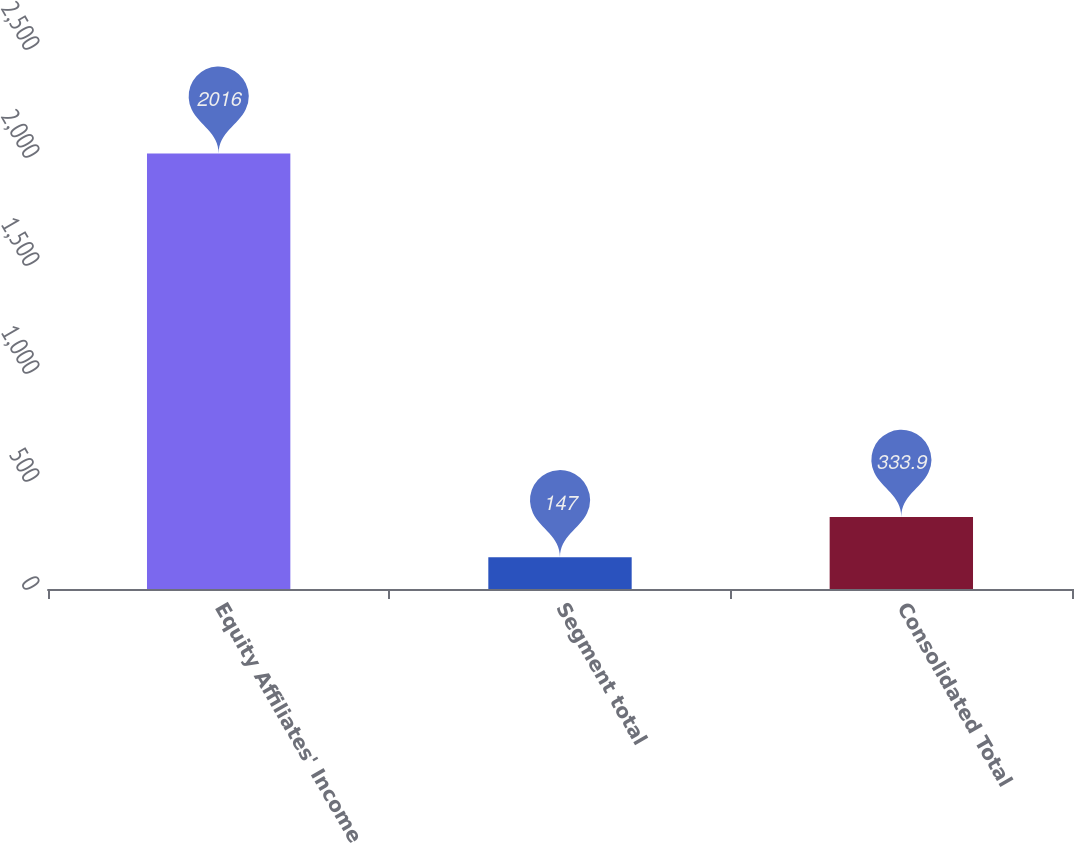Convert chart. <chart><loc_0><loc_0><loc_500><loc_500><bar_chart><fcel>Equity Affiliates' Income<fcel>Segment total<fcel>Consolidated Total<nl><fcel>2016<fcel>147<fcel>333.9<nl></chart> 